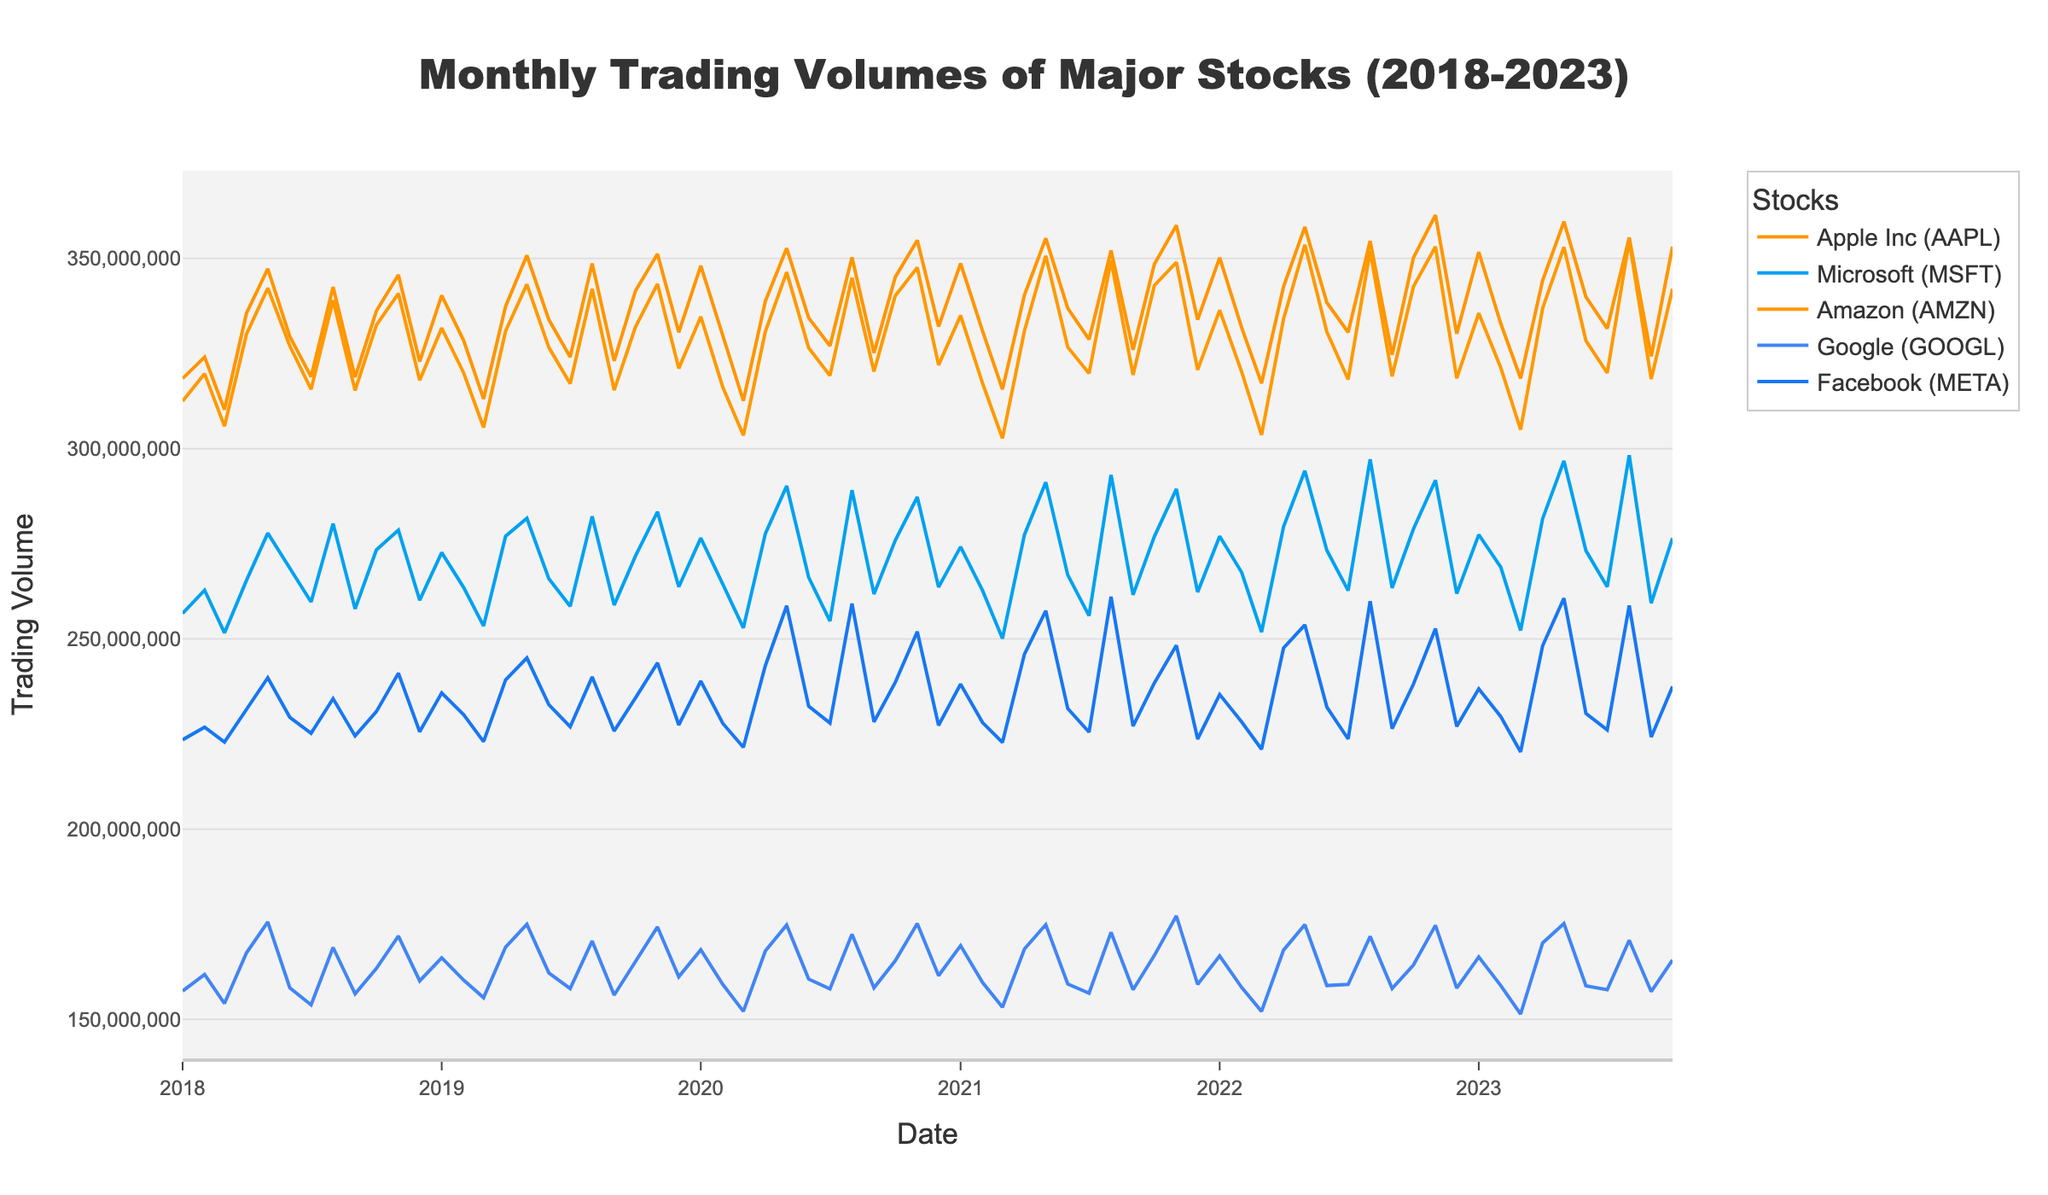What is the title of the figure? The title is typically placed at the top of the figure and describes its main idea or subject. In this case, the title reads "Monthly Trading Volumes of Major Stocks (2018-2023)".
Answer: Monthly Trading Volumes of Major Stocks (2018-2023) Which stock has the highest volume in October 2023? The figure presents monthly trading volumes over time for different stocks. By focusing on the data points for October 2023, you can see that "Facebook (META)" has the highest value.
Answer: Facebook (META) Which months show a peak trading volume for Apple Inc (AAPL)? Peaks in a time series plot are represented by data points that are distinctly higher than their neighbors. Looking through the Apple Inc (AAPL) plot line, May 2023 and August 2023 show notable peak volumes.
Answer: May 2023, August 2023 Compare the trading volumes of Google (GOOGL) and Amazon (AMZN) in June 2021. Which one is higher, and by how much? Locate the June 2021 trading volumes for both Google (GOOGL) and Amazon (AMZN). Google (GOOGL) has a trading volume of approximately 159.3 million, and Amazon (AMZN) has about 326.7 million. Subtracting Google's volume from Amazon's gives the difference.
Answer: Amazon (AMZN) is higher by about 167.4 million What trend is observed in the trading volume for Microsoft (MSFT) from January 2018 to October 2023? Identify the start and end points of the Microsoft (MSFT) series. From a visual analysis, the overall trend appears to be slowly increasing with some fluctuations.
Answer: Slowly increasing During which year did Google (GOOGL) show the most stable trading volume, with the least fluctuations? Stability in the trading volume is reflected by data points that stay relatively consistent. By visually scanning the series for Google (GOOGL), 2019 appears to have the least variations compared to other years.
Answer: 2019 In which year did Facebook (META) experience the highest average monthly trading volume? Calculate the average trading volume for each year by summing the monthly volumes and dividing by 12. Visually, Facebook (META) seems to peak in 2020 and 2021 more often, suggesting these years may have the highest average.
Answer: 2020 and 2021 have similarly high averages How does the trading volume of Apple Inc (AAPL) in March 2020 compare to March 2021? Locate both data points for March 2020 and March 2021 for Apple Inc (AAPL). The volume in March 2021 is generally higher than in March 2020.
Answer: March 2021 is higher What is the range of trading volumes for Amazon (AMZN) from July 2023 to October 2023? To find the range, identify the highest and lowest points in the series for Amazon (AMZN) between July 2023 and October 2023. Subtract the smallest volume from the largest volume observed.
Answer: Range is about 34,800,000 (354,700,000 - 320,000,000) What are the general trends for the trading volumes of Amazon (AMZN) and Facebook (META) over the five years? For Amazon (AMZN), the trend shows substantial increases with some fluctuations, especially around early 2020 and mid-2023. Meanwhile, Facebook (META) depicts a steady increasing trend, peaking in 2021 and 2022.
Answer: Increasing trends for both stocks, noticeable peaks for Amazon in 2020 and 2023, for Facebook in 2021 and 2022 